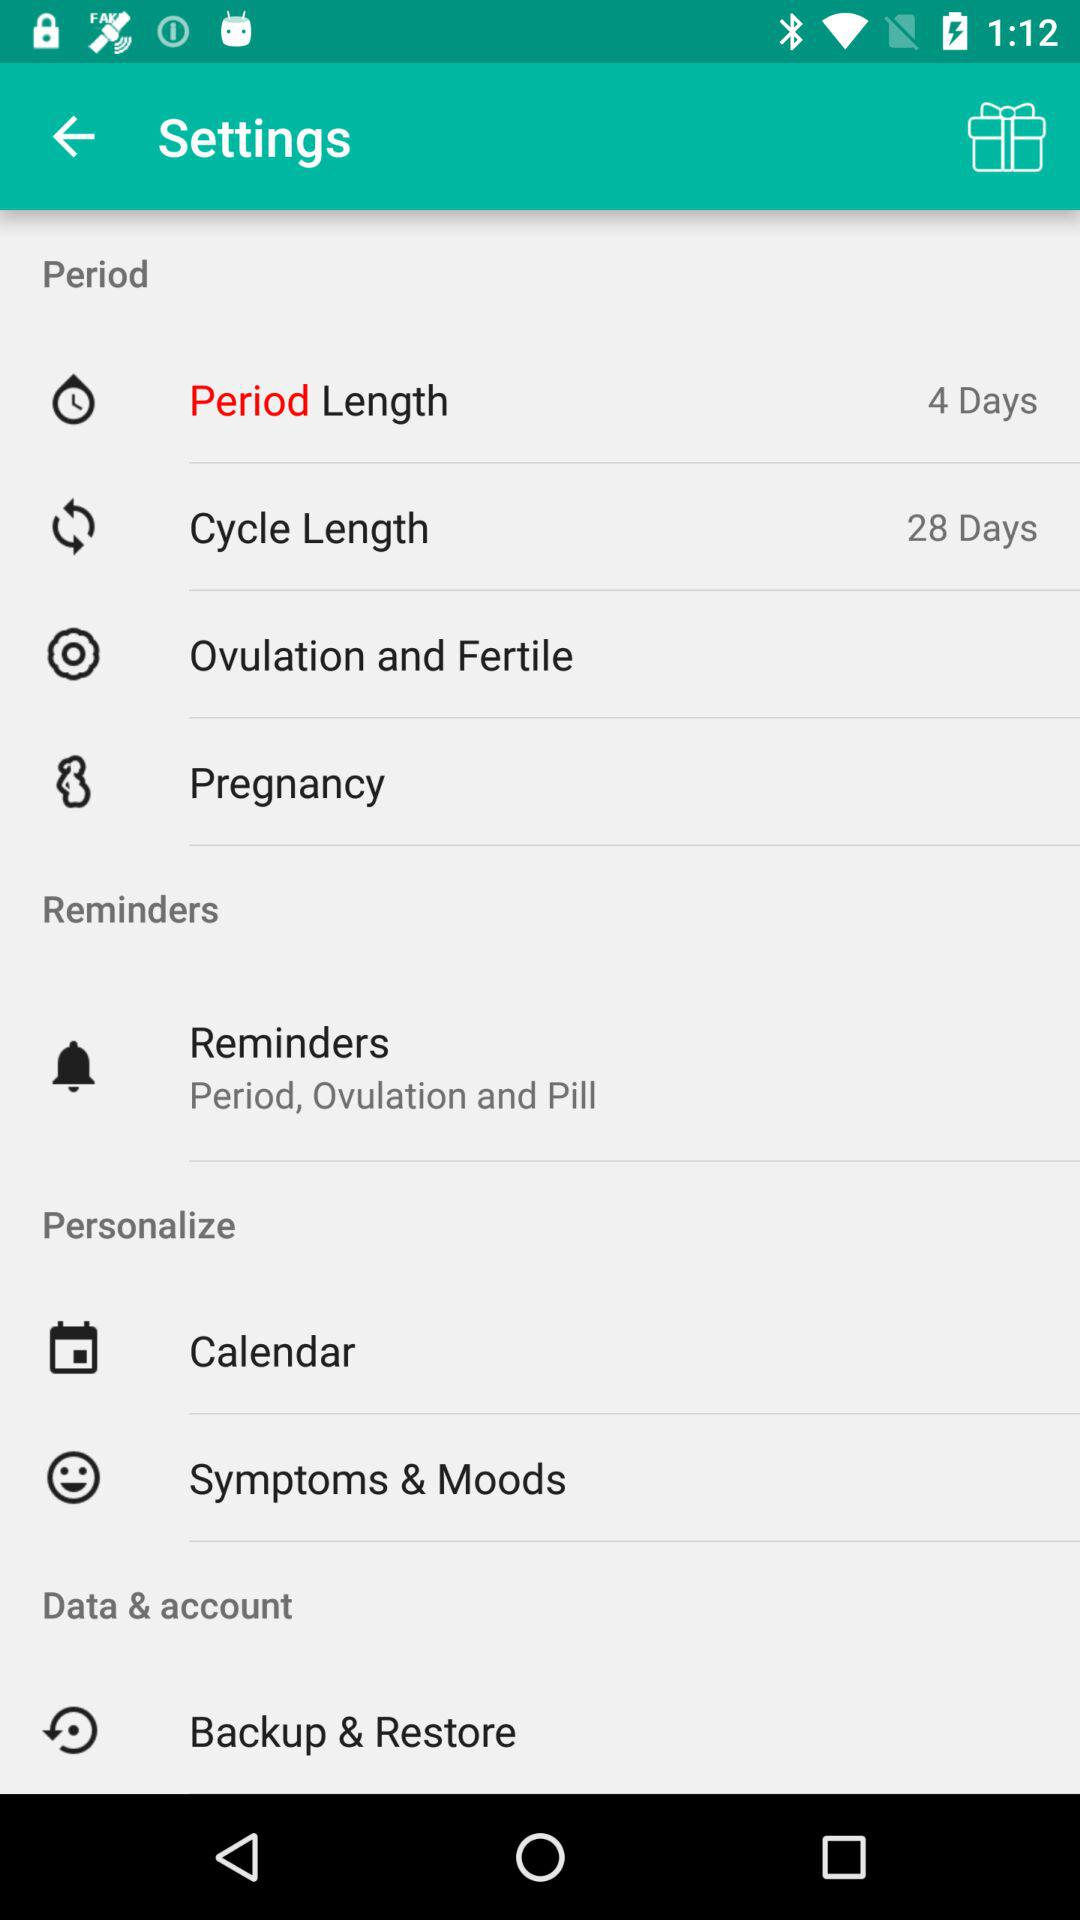How many more days are in the cycle length than in the period length?
Answer the question using a single word or phrase. 24 